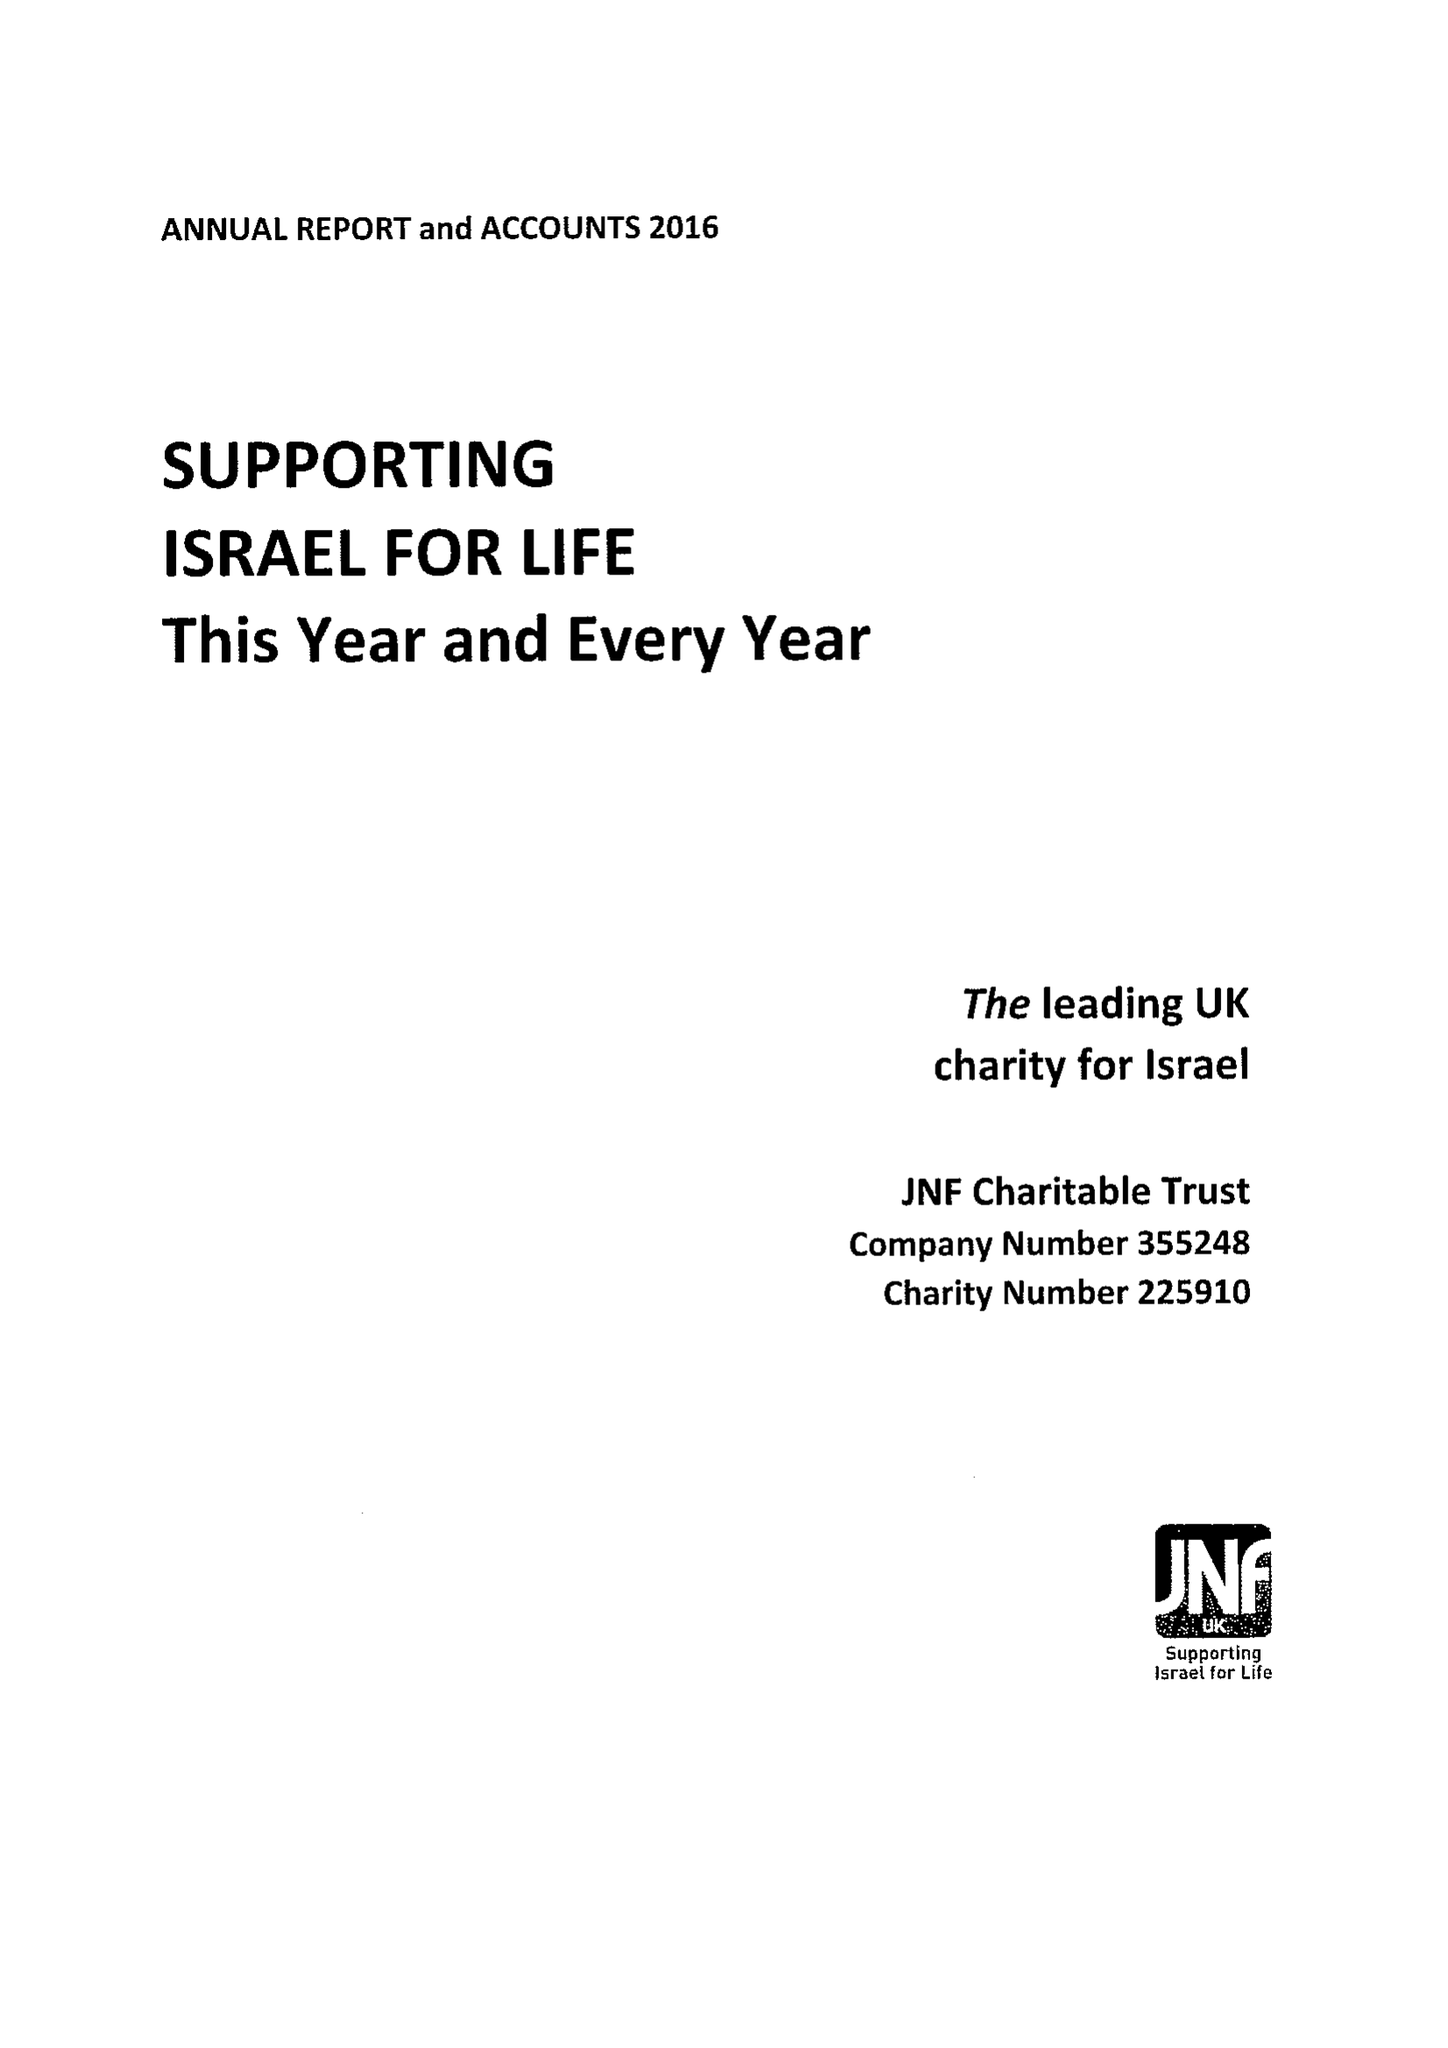What is the value for the address__post_town?
Answer the question using a single word or phrase. LONDON 